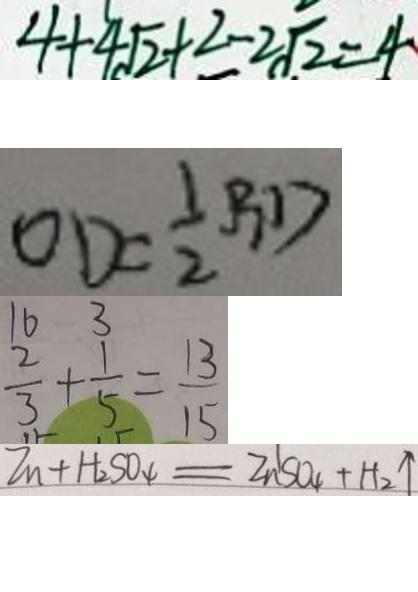Convert formula to latex. <formula><loc_0><loc_0><loc_500><loc_500>4 + 4 \sqrt { 2 } + 2 - 2 \sqrt { 2 } = 4 
 O D = \frac { 1 } { 2 } B D 
 \frac { 2 } { 3 } + \frac { 1 } { 5 } = \frac { 1 3 } { 1 5 } 
 Z n + H _ { 2 } S O _ { 4 } = Z n ^ { 1 } S O _ { 4 } + H _ { 2 } \uparrow</formula> 